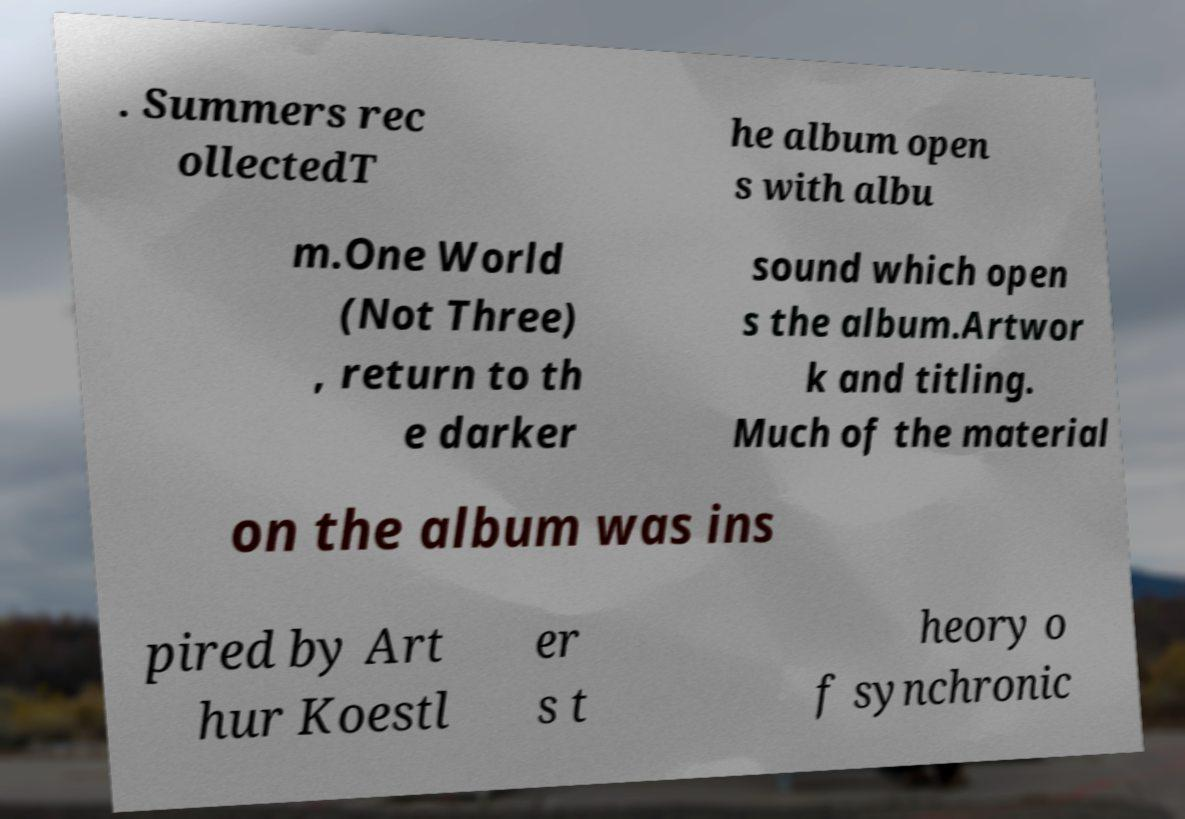Can you accurately transcribe the text from the provided image for me? . Summers rec ollectedT he album open s with albu m.One World (Not Three) , return to th e darker sound which open s the album.Artwor k and titling. Much of the material on the album was ins pired by Art hur Koestl er s t heory o f synchronic 